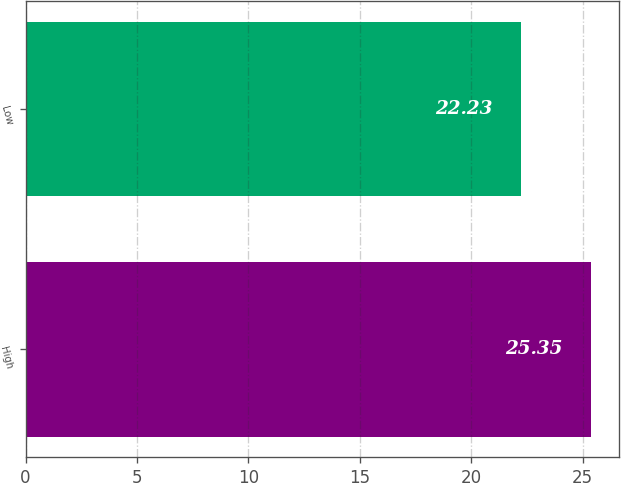Convert chart to OTSL. <chart><loc_0><loc_0><loc_500><loc_500><bar_chart><fcel>High<fcel>Low<nl><fcel>25.35<fcel>22.23<nl></chart> 